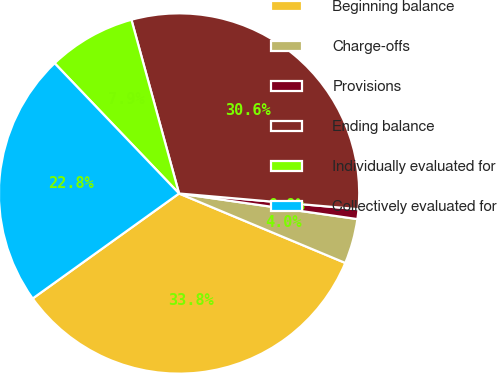Convert chart. <chart><loc_0><loc_0><loc_500><loc_500><pie_chart><fcel>Beginning balance<fcel>Charge-offs<fcel>Provisions<fcel>Ending balance<fcel>Individually evaluated for<fcel>Collectively evaluated for<nl><fcel>33.8%<fcel>4.03%<fcel>0.88%<fcel>30.65%<fcel>7.88%<fcel>22.77%<nl></chart> 